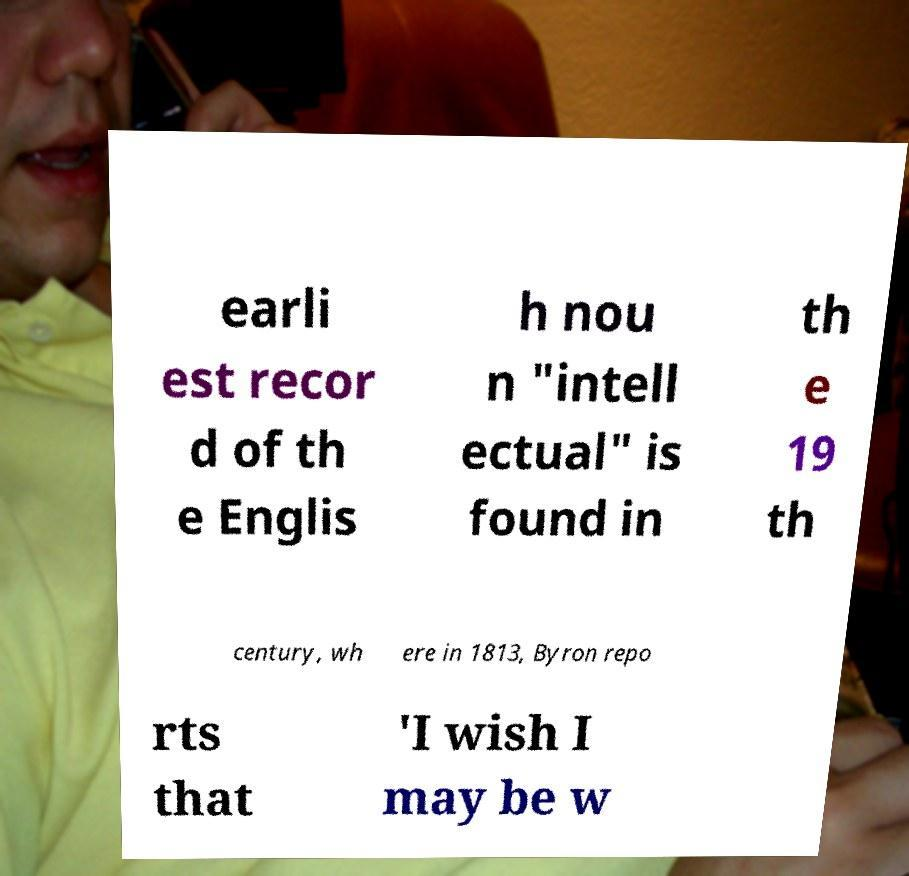For documentation purposes, I need the text within this image transcribed. Could you provide that? earli est recor d of th e Englis h nou n "intell ectual" is found in th e 19 th century, wh ere in 1813, Byron repo rts that 'I wish I may be w 